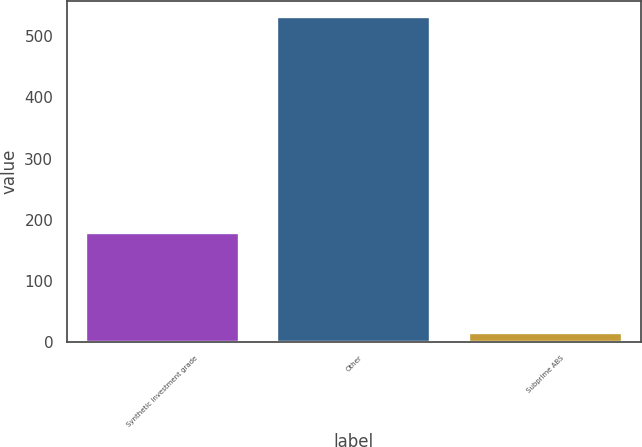Convert chart to OTSL. <chart><loc_0><loc_0><loc_500><loc_500><bar_chart><fcel>Synthetic investment grade<fcel>Other<fcel>Subprime ABS<nl><fcel>178<fcel>532<fcel>14<nl></chart> 